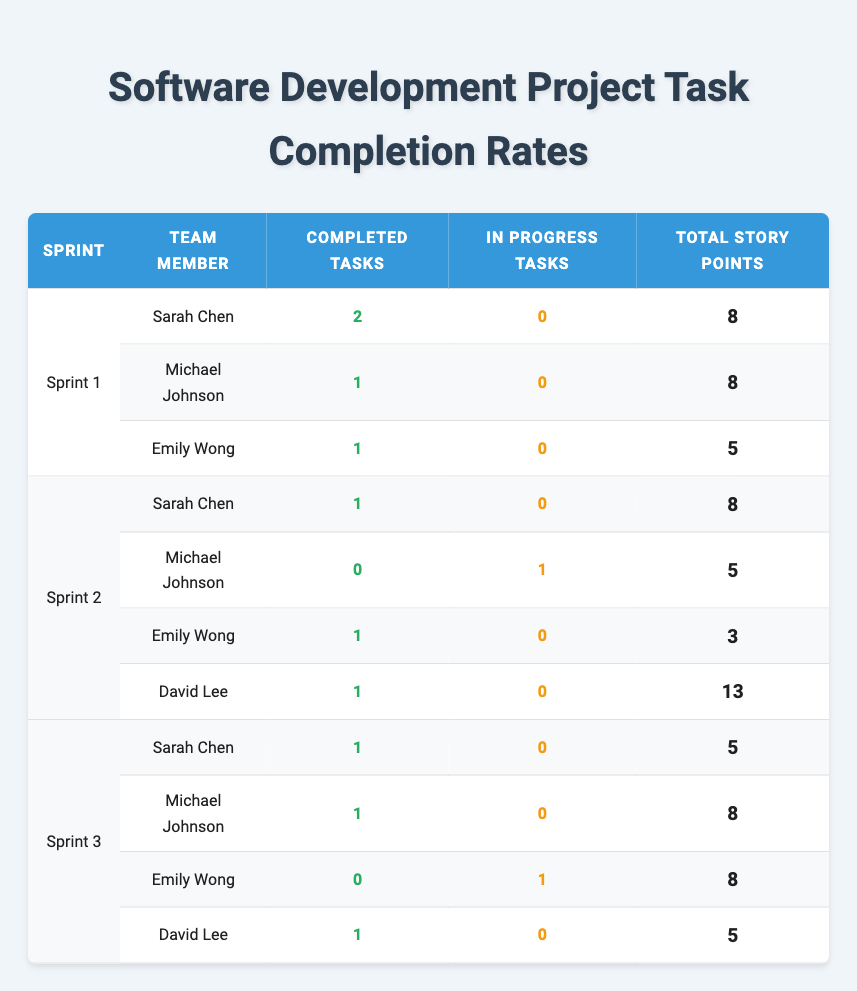What is the total number of completed tasks for Sarah Chen across all sprints? In Sprint 1, Sarah completed 2 tasks. In Sprint 2, she completed 1 task. In Sprint 3, she completed 1 task. Adding these gives 2 + 1 + 1 = 4 completed tasks.
Answer: 4 Which team member has the highest total story points among all sprints? Looking at all team members: Sarah Chen has 8 (Sprint 1) + 8 (Sprint 2) + 5 (Sprint 3) = 21 points. Michael Johnson has 8 (Sprint 1) + 0 (Sprint 2) + 8 (Sprint 3) = 16 points. Emily Wong has 5 (Sprint 1) + 3 (Sprint 2) + 8 (Sprint 3) = 16 points. David Lee has 13 (Sprint 2) + 5 (Sprint 3) = 18. Therefore, Sarah Chen has the highest with 21 points.
Answer: Sarah Chen Did Michael Johnson complete any tasks in Sprint 2? In Sprint 2, the table shows that Michael has 0 completed tasks and 1 task that is in progress. Therefore, he did not complete any tasks.
Answer: No How many total story points were achieved by the team in Sprint 1? Total story points for Sprint 1: Sarah (8) + Michael (8) + Emily (5) = 21 story points.
Answer: 21 Which sprint had the most in-progress tasks? From the table, Sprint 2 has 1 in-progress task from Michael Johnson. Sprints 1 and 3 have 0 in-progress tasks. Hence, Sprint 2 has the most.
Answer: Sprint 2 How many completed tasks did David Lee manage in Sprint 3? In Sprint 3, David Lee is listed with 1 completed task. Therefore, he managed 1 completed task in this sprint.
Answer: 1 What is the average number of completed tasks per team member in Sprint 3? In Sprint 3: 1 task by Sarah, 1 by Michael, 0 by Emily, and 1 by David, which totals 3 completed tasks. There are 4 team members, so the average is 3/4 = 0.75 completed tasks.
Answer: 0.75 Is there any team member who did not complete a task in Sprint 3? Yes, Emily Wong has 0 completed tasks in Sprint 3, according to the table.
Answer: Yes How many total tasks did Emily Wong complete across all sprints? In Sprint 1, Emily completed 1 task. In Sprint 2, she completed 1 task. In Sprint 3, she completed 0 tasks. The total is 1 + 1 + 0 = 2 completed tasks.
Answer: 2 